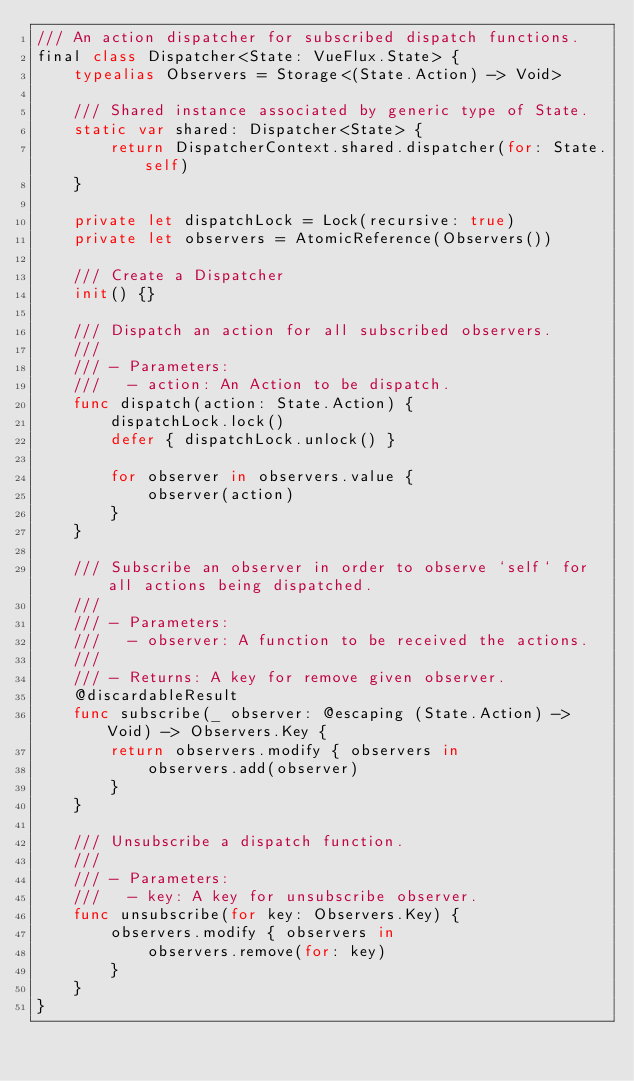Convert code to text. <code><loc_0><loc_0><loc_500><loc_500><_Swift_>/// An action dispatcher for subscribed dispatch functions.
final class Dispatcher<State: VueFlux.State> {
    typealias Observers = Storage<(State.Action) -> Void>
    
    /// Shared instance associated by generic type of State.
    static var shared: Dispatcher<State> {
        return DispatcherContext.shared.dispatcher(for: State.self)
    }
    
    private let dispatchLock = Lock(recursive: true)
    private let observers = AtomicReference(Observers())
    
    /// Create a Dispatcher
    init() {}
    
    /// Dispatch an action for all subscribed observers.
    ///
    /// - Parameters:
    ///   - action: An Action to be dispatch.
    func dispatch(action: State.Action) {
        dispatchLock.lock()
        defer { dispatchLock.unlock() }
        
        for observer in observers.value {
            observer(action)
        }
    }
    
    /// Subscribe an observer in order to observe `self` for all actions being dispatched.
    ///
    /// - Parameters:
    ///   - observer: A function to be received the actions.
    ///
    /// - Returns: A key for remove given observer.
    @discardableResult
    func subscribe(_ observer: @escaping (State.Action) -> Void) -> Observers.Key {
        return observers.modify { observers in
            observers.add(observer)
        }
    }
    
    /// Unsubscribe a dispatch function.
    ///
    /// - Parameters:
    ///   - key: A key for unsubscribe observer.
    func unsubscribe(for key: Observers.Key) {
        observers.modify { observers in
            observers.remove(for: key)
        }
    }
}
</code> 